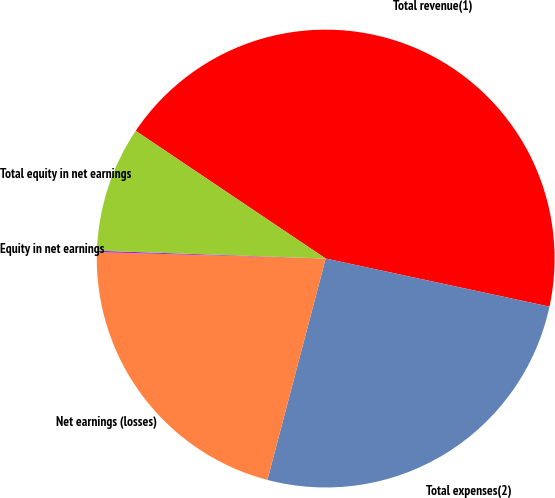<chart> <loc_0><loc_0><loc_500><loc_500><pie_chart><fcel>Total revenue(1)<fcel>Total expenses(2)<fcel>Net earnings (losses)<fcel>Equity in net earnings<fcel>Total equity in net earnings<nl><fcel>43.95%<fcel>25.73%<fcel>21.35%<fcel>0.1%<fcel>8.87%<nl></chart> 